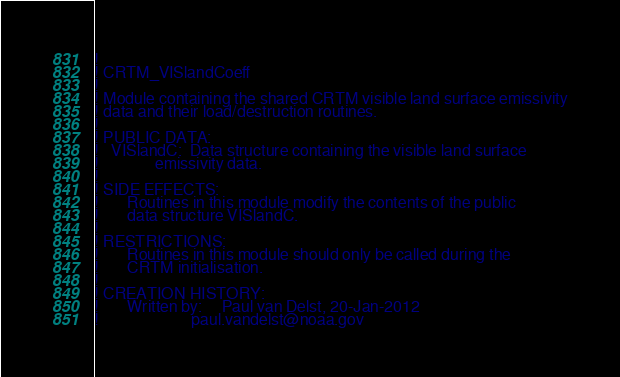Convert code to text. <code><loc_0><loc_0><loc_500><loc_500><_FORTRAN_>!
! CRTM_VISlandCoeff
!
! Module containing the shared CRTM visible land surface emissivity
! data and their load/destruction routines. 
!
! PUBLIC DATA:
!   VISlandC:  Data structure containing the visible land surface
!              emissivity data.
!
! SIDE EFFECTS:
!       Routines in this module modify the contents of the public
!       data structure VISlandC.
!
! RESTRICTIONS:
!       Routines in this module should only be called during the
!       CRTM initialisation.
!
! CREATION HISTORY:
!       Written by:     Paul van Delst, 20-Jan-2012
!                       paul.vandelst@noaa.gov</code> 